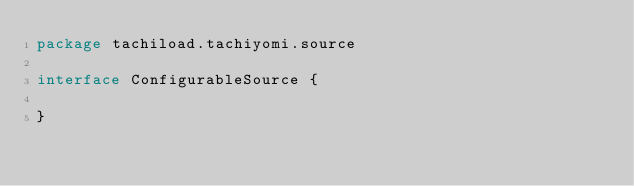Convert code to text. <code><loc_0><loc_0><loc_500><loc_500><_Kotlin_>package tachiload.tachiyomi.source

interface ConfigurableSource {

}
</code> 